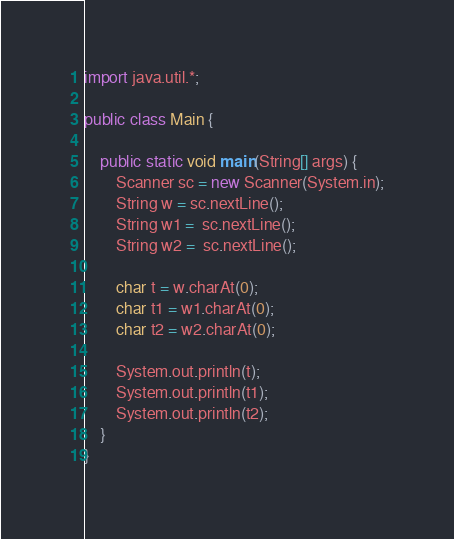<code> <loc_0><loc_0><loc_500><loc_500><_Java_>import java.util.*;

public class Main {

    public static void main(String[] args) {
        Scanner sc = new Scanner(System.in);
        String w = sc.nextLine();
        String w1 =  sc.nextLine();
        String w2 =  sc.nextLine();

        char t = w.charAt(0);
        char t1 = w1.charAt(0);
        char t2 = w2.charAt(0);

        System.out.println(t);
        System.out.println(t1);
        System.out.println(t2);
    }
}</code> 